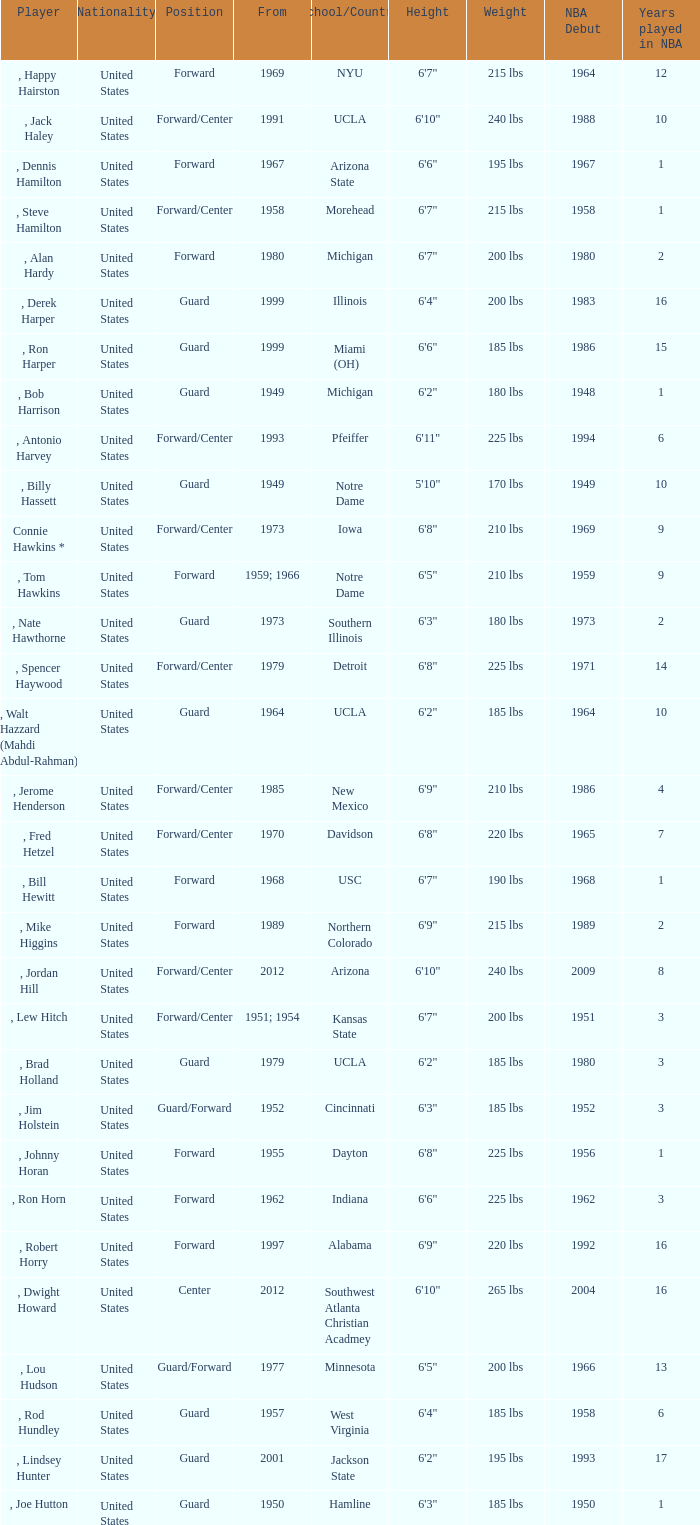What position was for Arizona State? Forward. 